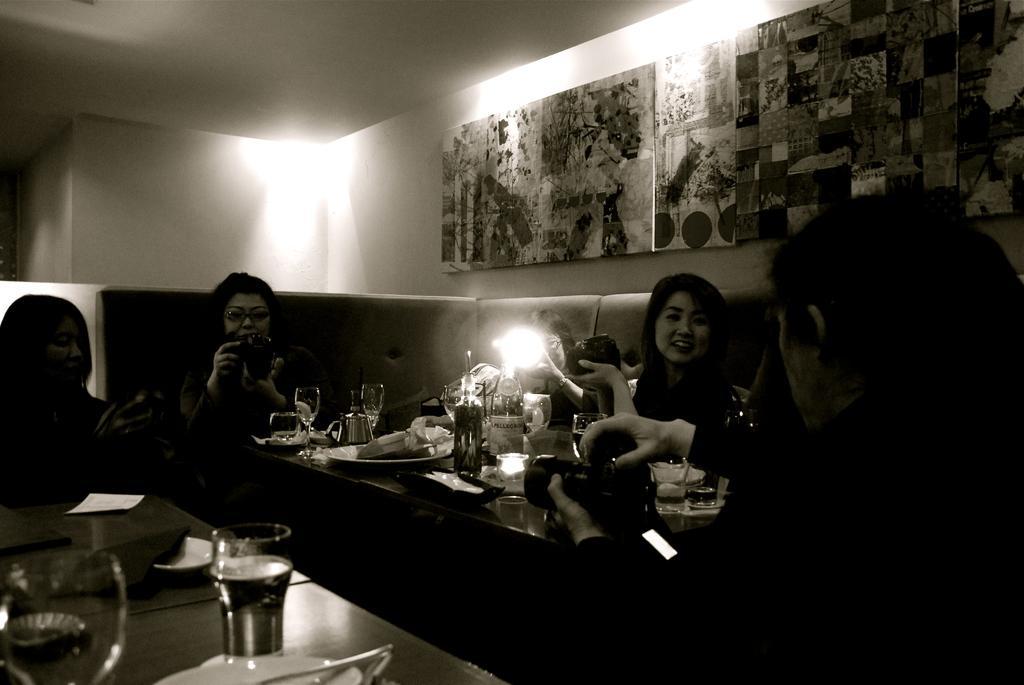Could you give a brief overview of what you see in this image? At the bottom of the image on the tables there are glasses, spoons, plates, bottles and some other things. Behind the table there are few people sitting on the sofa and holding cameras in their hands. Behind them there are frames on the wall and also there are lights. 